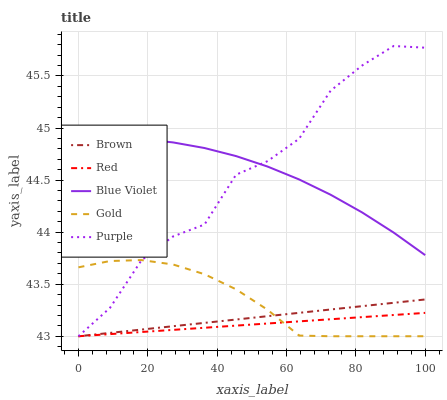Does Red have the minimum area under the curve?
Answer yes or no. Yes. Does Purple have the maximum area under the curve?
Answer yes or no. Yes. Does Brown have the minimum area under the curve?
Answer yes or no. No. Does Brown have the maximum area under the curve?
Answer yes or no. No. Is Red the smoothest?
Answer yes or no. Yes. Is Purple the roughest?
Answer yes or no. Yes. Is Brown the smoothest?
Answer yes or no. No. Is Brown the roughest?
Answer yes or no. No. Does Purple have the lowest value?
Answer yes or no. Yes. Does Blue Violet have the lowest value?
Answer yes or no. No. Does Purple have the highest value?
Answer yes or no. Yes. Does Brown have the highest value?
Answer yes or no. No. Is Red less than Blue Violet?
Answer yes or no. Yes. Is Blue Violet greater than Red?
Answer yes or no. Yes. Does Red intersect Gold?
Answer yes or no. Yes. Is Red less than Gold?
Answer yes or no. No. Is Red greater than Gold?
Answer yes or no. No. Does Red intersect Blue Violet?
Answer yes or no. No. 